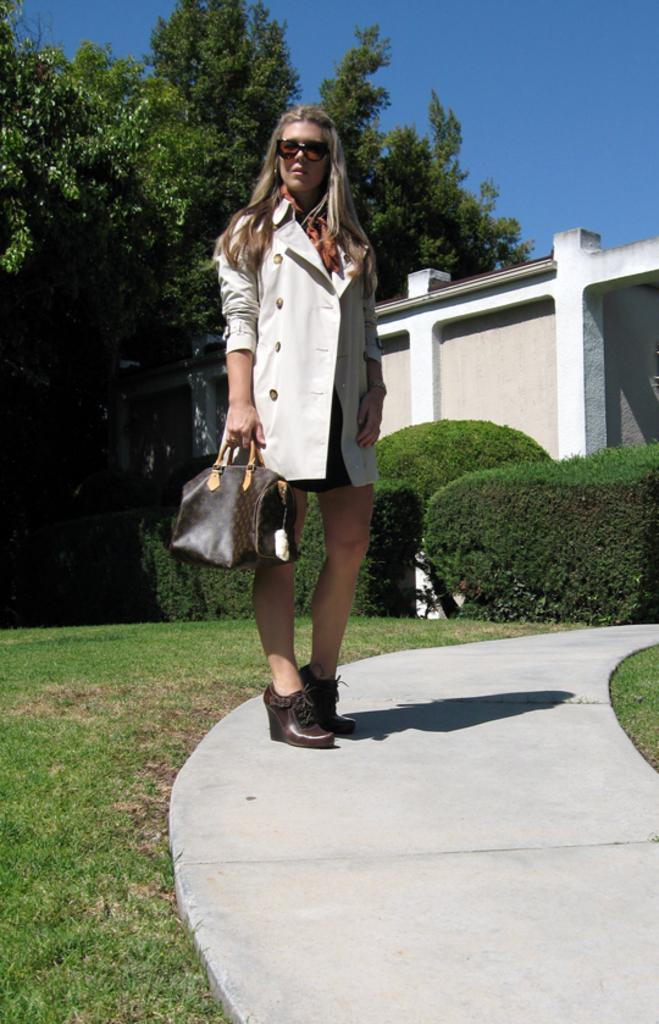Who is the main subject in the image? There is a lady in the image. What is the lady wearing? The lady is wearing a white jacket. What is the lady carrying in the image? The lady is carrying a bag. What can be seen in the background of the image? There is a building and trees in the background of the image. What type of bone can be seen in the lady's throat in the image? There is no bone or throat visible in the image; it only shows a lady wearing a white jacket and carrying a bag, with a background of a building and trees. 